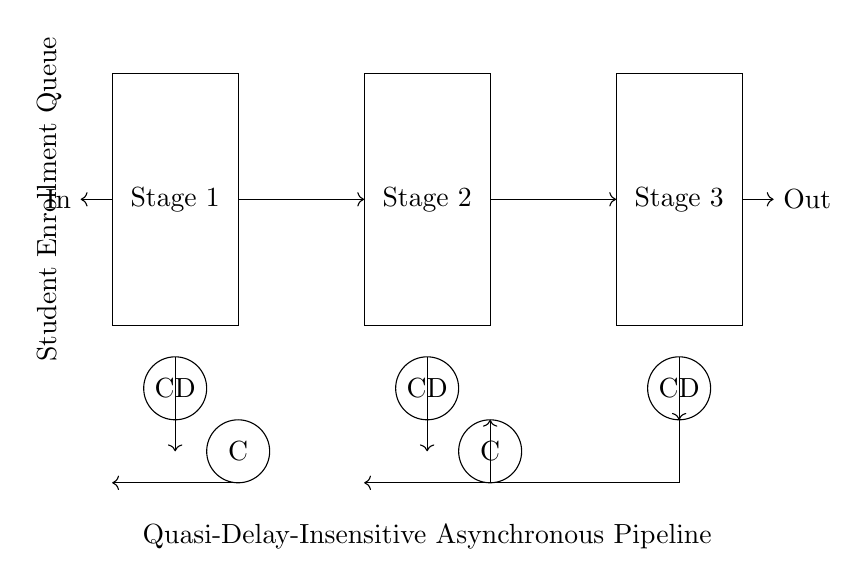What are the stages in this circuit? The circuit diagram features three rectangles labeled "Stage 1," "Stage 2," and "Stage 3," indicating the stages of the pipeline.
Answer: Stage 1, Stage 2, Stage 3 What are the components used for completion detection? There are three circles labeled "CD" at the bottom of the stages, showing that they are completion detectors for each stage.
Answer: CD How many C-elements are present in the circuit? The circuit diagram illustrates two circles labeled "C" that represent C-elements, confirming their count.
Answer: 2 What is the direction of data flow in this circuit? The arrows in the circuit indicate that data flows from the left (input) to the right (output), showing the movement of enrollment data through the pipeline stages.
Answer: Left to right What does the label "Quasi-Delay-Insensitive Asynchronous Pipeline" signify? This label indicates the type of pipeline being utilized in the management of student enrollment queues, emphasizing that it operates without specific timing constraints associated with synchronous circuits.
Answer: Quasi-Delay-Insensitive Asynchronous Pipeline Which component connects the stages of the pipeline? The arrows connecting the stages demonstrate the flow and interaction of data between different stages in the pipeline, ensuring proper sequencing.
Answer: Arrows What is the purpose of the Student Enrollment Queue label in the circuit? This label identifies the area of the circuit responsible for managing the flow of student enrollment requests, clarifying the circuit's application in processing enrollments.
Answer: Student Enrollment Queue 